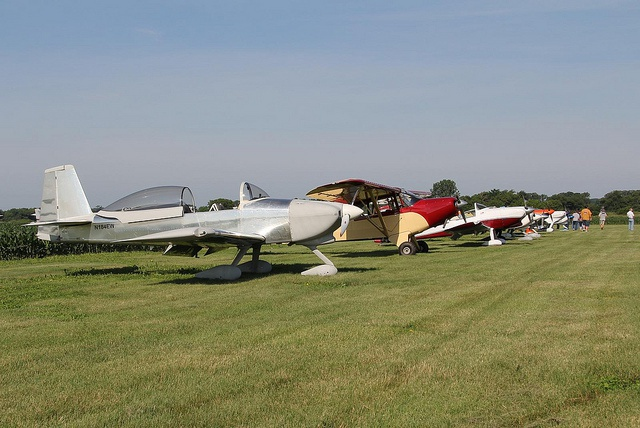Describe the objects in this image and their specific colors. I can see airplane in darkgray, lightgray, black, and gray tones, airplane in darkgray, black, olive, brown, and tan tones, airplane in darkgray, white, black, maroon, and gray tones, airplane in darkgray, lightgray, gray, and black tones, and people in darkgray, tan, black, orange, and brown tones in this image. 